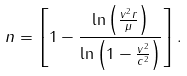<formula> <loc_0><loc_0><loc_500><loc_500>n = \left [ 1 - \frac { \ln \left ( \frac { v ^ { 2 } r } { \mu } \right ) } { \ln \left ( 1 - \frac { v ^ { 2 } } { c ^ { 2 } } \right ) } \right ] .</formula> 